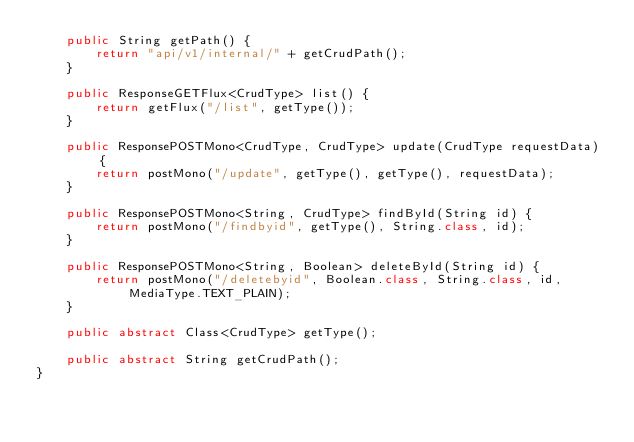<code> <loc_0><loc_0><loc_500><loc_500><_Java_>	public String getPath() {
		return "api/v1/internal/" + getCrudPath();
	}
	
	public ResponseGETFlux<CrudType> list() {
		return getFlux("/list", getType());
	}
	
	public ResponsePOSTMono<CrudType, CrudType> update(CrudType requestData) {
		return postMono("/update", getType(), getType(), requestData);
	}
	
	public ResponsePOSTMono<String, CrudType> findById(String id) {
		return postMono("/findbyid", getType(), String.class, id);
	}
	
	public ResponsePOSTMono<String, Boolean> deleteById(String id) {
		return postMono("/deletebyid", Boolean.class, String.class, id, MediaType.TEXT_PLAIN);
	}
	
	public abstract Class<CrudType> getType();
	
	public abstract String getCrudPath();
}</code> 